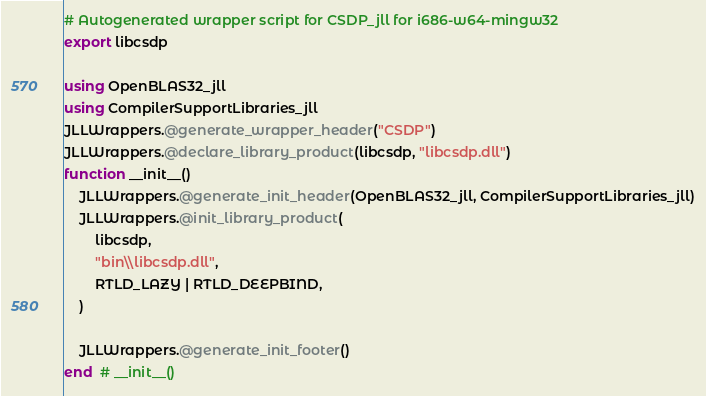Convert code to text. <code><loc_0><loc_0><loc_500><loc_500><_Julia_># Autogenerated wrapper script for CSDP_jll for i686-w64-mingw32
export libcsdp

using OpenBLAS32_jll
using CompilerSupportLibraries_jll
JLLWrappers.@generate_wrapper_header("CSDP")
JLLWrappers.@declare_library_product(libcsdp, "libcsdp.dll")
function __init__()
    JLLWrappers.@generate_init_header(OpenBLAS32_jll, CompilerSupportLibraries_jll)
    JLLWrappers.@init_library_product(
        libcsdp,
        "bin\\libcsdp.dll",
        RTLD_LAZY | RTLD_DEEPBIND,
    )

    JLLWrappers.@generate_init_footer()
end  # __init__()
</code> 